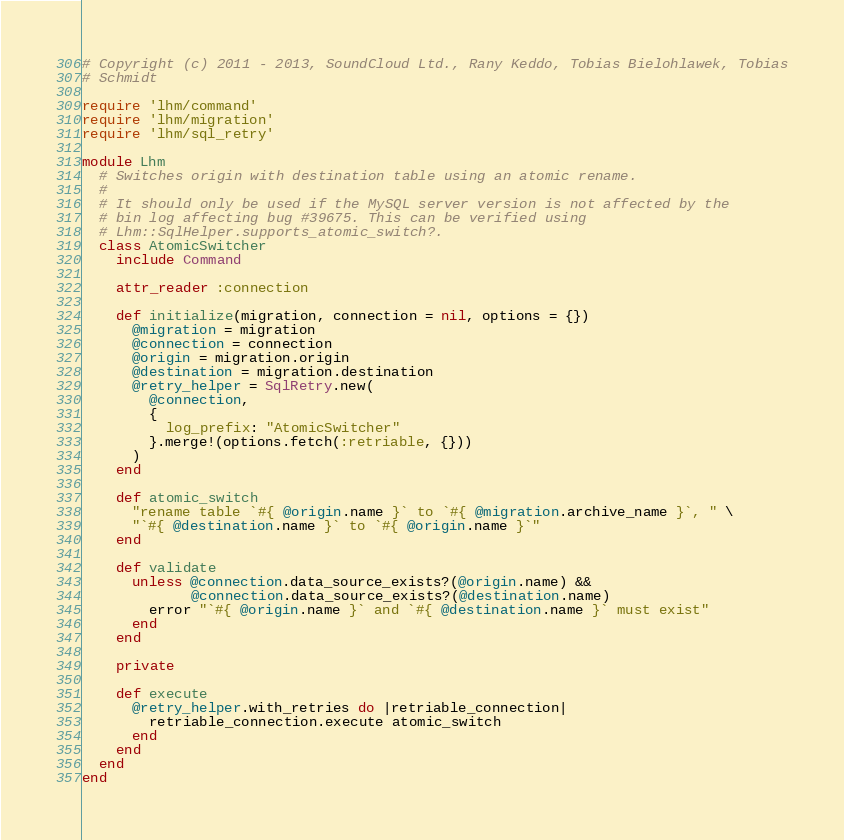Convert code to text. <code><loc_0><loc_0><loc_500><loc_500><_Ruby_># Copyright (c) 2011 - 2013, SoundCloud Ltd., Rany Keddo, Tobias Bielohlawek, Tobias
# Schmidt

require 'lhm/command'
require 'lhm/migration'
require 'lhm/sql_retry'

module Lhm
  # Switches origin with destination table using an atomic rename.
  #
  # It should only be used if the MySQL server version is not affected by the
  # bin log affecting bug #39675. This can be verified using
  # Lhm::SqlHelper.supports_atomic_switch?.
  class AtomicSwitcher
    include Command

    attr_reader :connection

    def initialize(migration, connection = nil, options = {})
      @migration = migration
      @connection = connection
      @origin = migration.origin
      @destination = migration.destination
      @retry_helper = SqlRetry.new(
        @connection,
        {
          log_prefix: "AtomicSwitcher"
        }.merge!(options.fetch(:retriable, {}))
      )
    end

    def atomic_switch
      "rename table `#{ @origin.name }` to `#{ @migration.archive_name }`, " \
      "`#{ @destination.name }` to `#{ @origin.name }`"
    end

    def validate
      unless @connection.data_source_exists?(@origin.name) &&
             @connection.data_source_exists?(@destination.name)
        error "`#{ @origin.name }` and `#{ @destination.name }` must exist"
      end
    end

    private

    def execute
      @retry_helper.with_retries do |retriable_connection|
        retriable_connection.execute atomic_switch
      end
    end
  end
end
</code> 